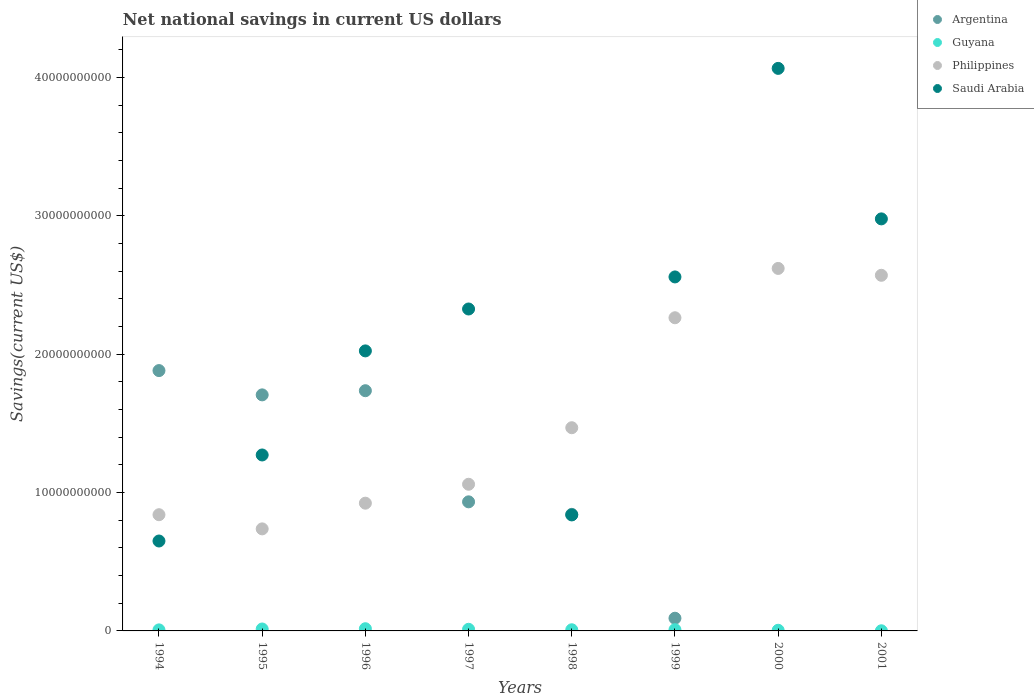Is the number of dotlines equal to the number of legend labels?
Give a very brief answer. No. What is the net national savings in Saudi Arabia in 1995?
Keep it short and to the point. 1.27e+1. Across all years, what is the maximum net national savings in Argentina?
Provide a succinct answer. 1.88e+1. Across all years, what is the minimum net national savings in Guyana?
Your response must be concise. 1.03e+07. In which year was the net national savings in Philippines maximum?
Make the answer very short. 2000. What is the total net national savings in Philippines in the graph?
Make the answer very short. 1.25e+11. What is the difference between the net national savings in Saudi Arabia in 1994 and that in 1997?
Your response must be concise. -1.68e+1. What is the difference between the net national savings in Saudi Arabia in 1998 and the net national savings in Argentina in 1995?
Your response must be concise. -8.68e+09. What is the average net national savings in Argentina per year?
Offer a very short reply. 8.99e+09. In the year 1996, what is the difference between the net national savings in Saudi Arabia and net national savings in Guyana?
Keep it short and to the point. 2.01e+1. What is the ratio of the net national savings in Saudi Arabia in 1995 to that in 1997?
Your answer should be very brief. 0.55. Is the net national savings in Saudi Arabia in 1997 less than that in 1998?
Provide a short and direct response. No. Is the difference between the net national savings in Saudi Arabia in 1995 and 2000 greater than the difference between the net national savings in Guyana in 1995 and 2000?
Make the answer very short. No. What is the difference between the highest and the second highest net national savings in Guyana?
Your answer should be compact. 1.91e+07. What is the difference between the highest and the lowest net national savings in Argentina?
Offer a terse response. 1.88e+1. Is the sum of the net national savings in Argentina in 1995 and 1996 greater than the maximum net national savings in Philippines across all years?
Your answer should be compact. Yes. Does the net national savings in Saudi Arabia monotonically increase over the years?
Offer a terse response. No. Is the net national savings in Guyana strictly greater than the net national savings in Argentina over the years?
Give a very brief answer. No. Is the net national savings in Saudi Arabia strictly less than the net national savings in Argentina over the years?
Your answer should be very brief. No. How many dotlines are there?
Your response must be concise. 4. How many years are there in the graph?
Make the answer very short. 8. What is the difference between two consecutive major ticks on the Y-axis?
Your answer should be very brief. 1.00e+1. Does the graph contain grids?
Offer a very short reply. No. How are the legend labels stacked?
Your answer should be very brief. Vertical. What is the title of the graph?
Ensure brevity in your answer.  Net national savings in current US dollars. What is the label or title of the Y-axis?
Provide a short and direct response. Savings(current US$). What is the Savings(current US$) of Argentina in 1994?
Make the answer very short. 1.88e+1. What is the Savings(current US$) of Guyana in 1994?
Ensure brevity in your answer.  7.51e+07. What is the Savings(current US$) in Philippines in 1994?
Offer a very short reply. 8.40e+09. What is the Savings(current US$) in Saudi Arabia in 1994?
Your answer should be very brief. 6.50e+09. What is the Savings(current US$) in Argentina in 1995?
Your answer should be compact. 1.71e+1. What is the Savings(current US$) of Guyana in 1995?
Provide a succinct answer. 1.39e+08. What is the Savings(current US$) in Philippines in 1995?
Provide a short and direct response. 7.38e+09. What is the Savings(current US$) in Saudi Arabia in 1995?
Give a very brief answer. 1.27e+1. What is the Savings(current US$) of Argentina in 1996?
Offer a very short reply. 1.74e+1. What is the Savings(current US$) of Guyana in 1996?
Make the answer very short. 1.58e+08. What is the Savings(current US$) of Philippines in 1996?
Make the answer very short. 9.23e+09. What is the Savings(current US$) of Saudi Arabia in 1996?
Provide a succinct answer. 2.02e+1. What is the Savings(current US$) in Argentina in 1997?
Keep it short and to the point. 9.33e+09. What is the Savings(current US$) of Guyana in 1997?
Make the answer very short. 1.18e+08. What is the Savings(current US$) of Philippines in 1997?
Your answer should be compact. 1.06e+1. What is the Savings(current US$) of Saudi Arabia in 1997?
Keep it short and to the point. 2.33e+1. What is the Savings(current US$) of Argentina in 1998?
Give a very brief answer. 8.43e+09. What is the Savings(current US$) of Guyana in 1998?
Your answer should be compact. 8.32e+07. What is the Savings(current US$) in Philippines in 1998?
Keep it short and to the point. 1.47e+1. What is the Savings(current US$) in Saudi Arabia in 1998?
Make the answer very short. 8.39e+09. What is the Savings(current US$) in Argentina in 1999?
Your answer should be very brief. 9.18e+08. What is the Savings(current US$) of Guyana in 1999?
Ensure brevity in your answer.  8.86e+07. What is the Savings(current US$) of Philippines in 1999?
Keep it short and to the point. 2.26e+1. What is the Savings(current US$) of Saudi Arabia in 1999?
Provide a succinct answer. 2.56e+1. What is the Savings(current US$) in Argentina in 2000?
Offer a very short reply. 0. What is the Savings(current US$) in Guyana in 2000?
Your answer should be very brief. 4.73e+07. What is the Savings(current US$) of Philippines in 2000?
Offer a very short reply. 2.62e+1. What is the Savings(current US$) of Saudi Arabia in 2000?
Keep it short and to the point. 4.07e+1. What is the Savings(current US$) in Argentina in 2001?
Your response must be concise. 0. What is the Savings(current US$) in Guyana in 2001?
Provide a succinct answer. 1.03e+07. What is the Savings(current US$) in Philippines in 2001?
Offer a terse response. 2.57e+1. What is the Savings(current US$) in Saudi Arabia in 2001?
Give a very brief answer. 2.98e+1. Across all years, what is the maximum Savings(current US$) of Argentina?
Make the answer very short. 1.88e+1. Across all years, what is the maximum Savings(current US$) of Guyana?
Offer a very short reply. 1.58e+08. Across all years, what is the maximum Savings(current US$) of Philippines?
Keep it short and to the point. 2.62e+1. Across all years, what is the maximum Savings(current US$) of Saudi Arabia?
Your response must be concise. 4.07e+1. Across all years, what is the minimum Savings(current US$) in Argentina?
Your answer should be compact. 0. Across all years, what is the minimum Savings(current US$) of Guyana?
Offer a very short reply. 1.03e+07. Across all years, what is the minimum Savings(current US$) in Philippines?
Keep it short and to the point. 7.38e+09. Across all years, what is the minimum Savings(current US$) in Saudi Arabia?
Your answer should be compact. 6.50e+09. What is the total Savings(current US$) in Argentina in the graph?
Provide a succinct answer. 7.19e+1. What is the total Savings(current US$) of Guyana in the graph?
Your answer should be compact. 7.20e+08. What is the total Savings(current US$) of Philippines in the graph?
Make the answer very short. 1.25e+11. What is the total Savings(current US$) in Saudi Arabia in the graph?
Make the answer very short. 1.67e+11. What is the difference between the Savings(current US$) in Argentina in 1994 and that in 1995?
Provide a succinct answer. 1.76e+09. What is the difference between the Savings(current US$) of Guyana in 1994 and that in 1995?
Offer a very short reply. -6.42e+07. What is the difference between the Savings(current US$) in Philippines in 1994 and that in 1995?
Your answer should be compact. 1.02e+09. What is the difference between the Savings(current US$) of Saudi Arabia in 1994 and that in 1995?
Your answer should be compact. -6.22e+09. What is the difference between the Savings(current US$) of Argentina in 1994 and that in 1996?
Provide a succinct answer. 1.45e+09. What is the difference between the Savings(current US$) in Guyana in 1994 and that in 1996?
Provide a short and direct response. -8.34e+07. What is the difference between the Savings(current US$) in Philippines in 1994 and that in 1996?
Offer a very short reply. -8.34e+08. What is the difference between the Savings(current US$) in Saudi Arabia in 1994 and that in 1996?
Your response must be concise. -1.37e+1. What is the difference between the Savings(current US$) of Argentina in 1994 and that in 1997?
Offer a terse response. 9.49e+09. What is the difference between the Savings(current US$) of Guyana in 1994 and that in 1997?
Ensure brevity in your answer.  -4.26e+07. What is the difference between the Savings(current US$) in Philippines in 1994 and that in 1997?
Provide a succinct answer. -2.20e+09. What is the difference between the Savings(current US$) of Saudi Arabia in 1994 and that in 1997?
Provide a succinct answer. -1.68e+1. What is the difference between the Savings(current US$) of Argentina in 1994 and that in 1998?
Your response must be concise. 1.04e+1. What is the difference between the Savings(current US$) of Guyana in 1994 and that in 1998?
Give a very brief answer. -8.11e+06. What is the difference between the Savings(current US$) of Philippines in 1994 and that in 1998?
Your response must be concise. -6.29e+09. What is the difference between the Savings(current US$) of Saudi Arabia in 1994 and that in 1998?
Offer a very short reply. -1.89e+09. What is the difference between the Savings(current US$) of Argentina in 1994 and that in 1999?
Your answer should be compact. 1.79e+1. What is the difference between the Savings(current US$) of Guyana in 1994 and that in 1999?
Give a very brief answer. -1.34e+07. What is the difference between the Savings(current US$) of Philippines in 1994 and that in 1999?
Your answer should be compact. -1.42e+1. What is the difference between the Savings(current US$) of Saudi Arabia in 1994 and that in 1999?
Give a very brief answer. -1.91e+1. What is the difference between the Savings(current US$) in Guyana in 1994 and that in 2000?
Provide a succinct answer. 2.78e+07. What is the difference between the Savings(current US$) of Philippines in 1994 and that in 2000?
Ensure brevity in your answer.  -1.78e+1. What is the difference between the Savings(current US$) of Saudi Arabia in 1994 and that in 2000?
Give a very brief answer. -3.42e+1. What is the difference between the Savings(current US$) in Guyana in 1994 and that in 2001?
Provide a succinct answer. 6.49e+07. What is the difference between the Savings(current US$) of Philippines in 1994 and that in 2001?
Offer a very short reply. -1.73e+1. What is the difference between the Savings(current US$) of Saudi Arabia in 1994 and that in 2001?
Your answer should be compact. -2.33e+1. What is the difference between the Savings(current US$) in Argentina in 1995 and that in 1996?
Your answer should be compact. -3.01e+08. What is the difference between the Savings(current US$) of Guyana in 1995 and that in 1996?
Your answer should be very brief. -1.91e+07. What is the difference between the Savings(current US$) of Philippines in 1995 and that in 1996?
Ensure brevity in your answer.  -1.86e+09. What is the difference between the Savings(current US$) in Saudi Arabia in 1995 and that in 1996?
Your answer should be compact. -7.52e+09. What is the difference between the Savings(current US$) of Argentina in 1995 and that in 1997?
Your response must be concise. 7.73e+09. What is the difference between the Savings(current US$) in Guyana in 1995 and that in 1997?
Provide a short and direct response. 2.16e+07. What is the difference between the Savings(current US$) of Philippines in 1995 and that in 1997?
Give a very brief answer. -3.23e+09. What is the difference between the Savings(current US$) in Saudi Arabia in 1995 and that in 1997?
Give a very brief answer. -1.06e+1. What is the difference between the Savings(current US$) of Argentina in 1995 and that in 1998?
Keep it short and to the point. 8.64e+09. What is the difference between the Savings(current US$) in Guyana in 1995 and that in 1998?
Ensure brevity in your answer.  5.61e+07. What is the difference between the Savings(current US$) of Philippines in 1995 and that in 1998?
Offer a very short reply. -7.31e+09. What is the difference between the Savings(current US$) in Saudi Arabia in 1995 and that in 1998?
Provide a short and direct response. 4.33e+09. What is the difference between the Savings(current US$) in Argentina in 1995 and that in 1999?
Ensure brevity in your answer.  1.61e+1. What is the difference between the Savings(current US$) of Guyana in 1995 and that in 1999?
Offer a terse response. 5.08e+07. What is the difference between the Savings(current US$) of Philippines in 1995 and that in 1999?
Provide a succinct answer. -1.53e+1. What is the difference between the Savings(current US$) of Saudi Arabia in 1995 and that in 1999?
Provide a succinct answer. -1.29e+1. What is the difference between the Savings(current US$) in Guyana in 1995 and that in 2000?
Make the answer very short. 9.21e+07. What is the difference between the Savings(current US$) of Philippines in 1995 and that in 2000?
Your response must be concise. -1.88e+1. What is the difference between the Savings(current US$) of Saudi Arabia in 1995 and that in 2000?
Provide a short and direct response. -2.79e+1. What is the difference between the Savings(current US$) of Guyana in 1995 and that in 2001?
Ensure brevity in your answer.  1.29e+08. What is the difference between the Savings(current US$) in Philippines in 1995 and that in 2001?
Offer a very short reply. -1.83e+1. What is the difference between the Savings(current US$) of Saudi Arabia in 1995 and that in 2001?
Provide a succinct answer. -1.71e+1. What is the difference between the Savings(current US$) in Argentina in 1996 and that in 1997?
Your answer should be compact. 8.03e+09. What is the difference between the Savings(current US$) of Guyana in 1996 and that in 1997?
Make the answer very short. 4.07e+07. What is the difference between the Savings(current US$) of Philippines in 1996 and that in 1997?
Provide a succinct answer. -1.37e+09. What is the difference between the Savings(current US$) of Saudi Arabia in 1996 and that in 1997?
Provide a succinct answer. -3.03e+09. What is the difference between the Savings(current US$) in Argentina in 1996 and that in 1998?
Your answer should be very brief. 8.94e+09. What is the difference between the Savings(current US$) of Guyana in 1996 and that in 1998?
Your answer should be very brief. 7.53e+07. What is the difference between the Savings(current US$) in Philippines in 1996 and that in 1998?
Provide a short and direct response. -5.45e+09. What is the difference between the Savings(current US$) in Saudi Arabia in 1996 and that in 1998?
Make the answer very short. 1.19e+1. What is the difference between the Savings(current US$) in Argentina in 1996 and that in 1999?
Keep it short and to the point. 1.64e+1. What is the difference between the Savings(current US$) of Guyana in 1996 and that in 1999?
Offer a terse response. 6.99e+07. What is the difference between the Savings(current US$) in Philippines in 1996 and that in 1999?
Ensure brevity in your answer.  -1.34e+1. What is the difference between the Savings(current US$) of Saudi Arabia in 1996 and that in 1999?
Offer a terse response. -5.35e+09. What is the difference between the Savings(current US$) in Guyana in 1996 and that in 2000?
Your answer should be very brief. 1.11e+08. What is the difference between the Savings(current US$) of Philippines in 1996 and that in 2000?
Keep it short and to the point. -1.70e+1. What is the difference between the Savings(current US$) of Saudi Arabia in 1996 and that in 2000?
Keep it short and to the point. -2.04e+1. What is the difference between the Savings(current US$) in Guyana in 1996 and that in 2001?
Your answer should be very brief. 1.48e+08. What is the difference between the Savings(current US$) in Philippines in 1996 and that in 2001?
Make the answer very short. -1.65e+1. What is the difference between the Savings(current US$) of Saudi Arabia in 1996 and that in 2001?
Your answer should be compact. -9.54e+09. What is the difference between the Savings(current US$) of Argentina in 1997 and that in 1998?
Your response must be concise. 9.04e+08. What is the difference between the Savings(current US$) in Guyana in 1997 and that in 1998?
Provide a succinct answer. 3.45e+07. What is the difference between the Savings(current US$) of Philippines in 1997 and that in 1998?
Ensure brevity in your answer.  -4.09e+09. What is the difference between the Savings(current US$) of Saudi Arabia in 1997 and that in 1998?
Make the answer very short. 1.49e+1. What is the difference between the Savings(current US$) in Argentina in 1997 and that in 1999?
Your answer should be compact. 8.41e+09. What is the difference between the Savings(current US$) in Guyana in 1997 and that in 1999?
Provide a short and direct response. 2.92e+07. What is the difference between the Savings(current US$) in Philippines in 1997 and that in 1999?
Your answer should be very brief. -1.20e+1. What is the difference between the Savings(current US$) in Saudi Arabia in 1997 and that in 1999?
Offer a terse response. -2.32e+09. What is the difference between the Savings(current US$) of Guyana in 1997 and that in 2000?
Your response must be concise. 7.05e+07. What is the difference between the Savings(current US$) in Philippines in 1997 and that in 2000?
Provide a short and direct response. -1.56e+1. What is the difference between the Savings(current US$) of Saudi Arabia in 1997 and that in 2000?
Offer a very short reply. -1.74e+1. What is the difference between the Savings(current US$) in Guyana in 1997 and that in 2001?
Offer a very short reply. 1.07e+08. What is the difference between the Savings(current US$) of Philippines in 1997 and that in 2001?
Ensure brevity in your answer.  -1.51e+1. What is the difference between the Savings(current US$) of Saudi Arabia in 1997 and that in 2001?
Provide a short and direct response. -6.51e+09. What is the difference between the Savings(current US$) of Argentina in 1998 and that in 1999?
Keep it short and to the point. 7.51e+09. What is the difference between the Savings(current US$) in Guyana in 1998 and that in 1999?
Your response must be concise. -5.34e+06. What is the difference between the Savings(current US$) of Philippines in 1998 and that in 1999?
Keep it short and to the point. -7.95e+09. What is the difference between the Savings(current US$) in Saudi Arabia in 1998 and that in 1999?
Your answer should be compact. -1.72e+1. What is the difference between the Savings(current US$) in Guyana in 1998 and that in 2000?
Ensure brevity in your answer.  3.59e+07. What is the difference between the Savings(current US$) of Philippines in 1998 and that in 2000?
Your answer should be very brief. -1.15e+1. What is the difference between the Savings(current US$) of Saudi Arabia in 1998 and that in 2000?
Offer a terse response. -3.23e+1. What is the difference between the Savings(current US$) in Guyana in 1998 and that in 2001?
Provide a short and direct response. 7.30e+07. What is the difference between the Savings(current US$) of Philippines in 1998 and that in 2001?
Provide a short and direct response. -1.10e+1. What is the difference between the Savings(current US$) in Saudi Arabia in 1998 and that in 2001?
Provide a short and direct response. -2.14e+1. What is the difference between the Savings(current US$) in Guyana in 1999 and that in 2000?
Provide a succinct answer. 4.13e+07. What is the difference between the Savings(current US$) in Philippines in 1999 and that in 2000?
Provide a succinct answer. -3.57e+09. What is the difference between the Savings(current US$) in Saudi Arabia in 1999 and that in 2000?
Provide a short and direct response. -1.51e+1. What is the difference between the Savings(current US$) of Guyana in 1999 and that in 2001?
Your response must be concise. 7.83e+07. What is the difference between the Savings(current US$) in Philippines in 1999 and that in 2001?
Make the answer very short. -3.07e+09. What is the difference between the Savings(current US$) of Saudi Arabia in 1999 and that in 2001?
Keep it short and to the point. -4.20e+09. What is the difference between the Savings(current US$) in Guyana in 2000 and that in 2001?
Give a very brief answer. 3.70e+07. What is the difference between the Savings(current US$) of Philippines in 2000 and that in 2001?
Keep it short and to the point. 4.96e+08. What is the difference between the Savings(current US$) in Saudi Arabia in 2000 and that in 2001?
Give a very brief answer. 1.09e+1. What is the difference between the Savings(current US$) of Argentina in 1994 and the Savings(current US$) of Guyana in 1995?
Provide a succinct answer. 1.87e+1. What is the difference between the Savings(current US$) in Argentina in 1994 and the Savings(current US$) in Philippines in 1995?
Keep it short and to the point. 1.14e+1. What is the difference between the Savings(current US$) of Argentina in 1994 and the Savings(current US$) of Saudi Arabia in 1995?
Offer a terse response. 6.10e+09. What is the difference between the Savings(current US$) in Guyana in 1994 and the Savings(current US$) in Philippines in 1995?
Your answer should be compact. -7.30e+09. What is the difference between the Savings(current US$) of Guyana in 1994 and the Savings(current US$) of Saudi Arabia in 1995?
Provide a succinct answer. -1.26e+1. What is the difference between the Savings(current US$) of Philippines in 1994 and the Savings(current US$) of Saudi Arabia in 1995?
Your answer should be very brief. -4.32e+09. What is the difference between the Savings(current US$) of Argentina in 1994 and the Savings(current US$) of Guyana in 1996?
Provide a succinct answer. 1.87e+1. What is the difference between the Savings(current US$) of Argentina in 1994 and the Savings(current US$) of Philippines in 1996?
Provide a short and direct response. 9.58e+09. What is the difference between the Savings(current US$) in Argentina in 1994 and the Savings(current US$) in Saudi Arabia in 1996?
Provide a short and direct response. -1.42e+09. What is the difference between the Savings(current US$) in Guyana in 1994 and the Savings(current US$) in Philippines in 1996?
Offer a very short reply. -9.16e+09. What is the difference between the Savings(current US$) in Guyana in 1994 and the Savings(current US$) in Saudi Arabia in 1996?
Keep it short and to the point. -2.02e+1. What is the difference between the Savings(current US$) of Philippines in 1994 and the Savings(current US$) of Saudi Arabia in 1996?
Your answer should be very brief. -1.18e+1. What is the difference between the Savings(current US$) in Argentina in 1994 and the Savings(current US$) in Guyana in 1997?
Provide a succinct answer. 1.87e+1. What is the difference between the Savings(current US$) in Argentina in 1994 and the Savings(current US$) in Philippines in 1997?
Your response must be concise. 8.22e+09. What is the difference between the Savings(current US$) in Argentina in 1994 and the Savings(current US$) in Saudi Arabia in 1997?
Provide a short and direct response. -4.45e+09. What is the difference between the Savings(current US$) of Guyana in 1994 and the Savings(current US$) of Philippines in 1997?
Your answer should be compact. -1.05e+1. What is the difference between the Savings(current US$) in Guyana in 1994 and the Savings(current US$) in Saudi Arabia in 1997?
Provide a short and direct response. -2.32e+1. What is the difference between the Savings(current US$) in Philippines in 1994 and the Savings(current US$) in Saudi Arabia in 1997?
Provide a short and direct response. -1.49e+1. What is the difference between the Savings(current US$) in Argentina in 1994 and the Savings(current US$) in Guyana in 1998?
Give a very brief answer. 1.87e+1. What is the difference between the Savings(current US$) in Argentina in 1994 and the Savings(current US$) in Philippines in 1998?
Keep it short and to the point. 4.13e+09. What is the difference between the Savings(current US$) of Argentina in 1994 and the Savings(current US$) of Saudi Arabia in 1998?
Your answer should be compact. 1.04e+1. What is the difference between the Savings(current US$) in Guyana in 1994 and the Savings(current US$) in Philippines in 1998?
Offer a terse response. -1.46e+1. What is the difference between the Savings(current US$) in Guyana in 1994 and the Savings(current US$) in Saudi Arabia in 1998?
Provide a succinct answer. -8.31e+09. What is the difference between the Savings(current US$) of Philippines in 1994 and the Savings(current US$) of Saudi Arabia in 1998?
Offer a terse response. 1.50e+07. What is the difference between the Savings(current US$) in Argentina in 1994 and the Savings(current US$) in Guyana in 1999?
Ensure brevity in your answer.  1.87e+1. What is the difference between the Savings(current US$) of Argentina in 1994 and the Savings(current US$) of Philippines in 1999?
Offer a terse response. -3.82e+09. What is the difference between the Savings(current US$) in Argentina in 1994 and the Savings(current US$) in Saudi Arabia in 1999?
Provide a short and direct response. -6.77e+09. What is the difference between the Savings(current US$) in Guyana in 1994 and the Savings(current US$) in Philippines in 1999?
Your answer should be compact. -2.26e+1. What is the difference between the Savings(current US$) of Guyana in 1994 and the Savings(current US$) of Saudi Arabia in 1999?
Make the answer very short. -2.55e+1. What is the difference between the Savings(current US$) of Philippines in 1994 and the Savings(current US$) of Saudi Arabia in 1999?
Your response must be concise. -1.72e+1. What is the difference between the Savings(current US$) in Argentina in 1994 and the Savings(current US$) in Guyana in 2000?
Ensure brevity in your answer.  1.88e+1. What is the difference between the Savings(current US$) of Argentina in 1994 and the Savings(current US$) of Philippines in 2000?
Ensure brevity in your answer.  -7.39e+09. What is the difference between the Savings(current US$) of Argentina in 1994 and the Savings(current US$) of Saudi Arabia in 2000?
Your answer should be very brief. -2.18e+1. What is the difference between the Savings(current US$) of Guyana in 1994 and the Savings(current US$) of Philippines in 2000?
Your answer should be very brief. -2.61e+1. What is the difference between the Savings(current US$) of Guyana in 1994 and the Savings(current US$) of Saudi Arabia in 2000?
Provide a short and direct response. -4.06e+1. What is the difference between the Savings(current US$) in Philippines in 1994 and the Savings(current US$) in Saudi Arabia in 2000?
Provide a succinct answer. -3.23e+1. What is the difference between the Savings(current US$) in Argentina in 1994 and the Savings(current US$) in Guyana in 2001?
Offer a terse response. 1.88e+1. What is the difference between the Savings(current US$) in Argentina in 1994 and the Savings(current US$) in Philippines in 2001?
Make the answer very short. -6.89e+09. What is the difference between the Savings(current US$) of Argentina in 1994 and the Savings(current US$) of Saudi Arabia in 2001?
Keep it short and to the point. -1.10e+1. What is the difference between the Savings(current US$) of Guyana in 1994 and the Savings(current US$) of Philippines in 2001?
Your answer should be very brief. -2.56e+1. What is the difference between the Savings(current US$) in Guyana in 1994 and the Savings(current US$) in Saudi Arabia in 2001?
Provide a succinct answer. -2.97e+1. What is the difference between the Savings(current US$) in Philippines in 1994 and the Savings(current US$) in Saudi Arabia in 2001?
Offer a very short reply. -2.14e+1. What is the difference between the Savings(current US$) in Argentina in 1995 and the Savings(current US$) in Guyana in 1996?
Your answer should be very brief. 1.69e+1. What is the difference between the Savings(current US$) of Argentina in 1995 and the Savings(current US$) of Philippines in 1996?
Make the answer very short. 7.83e+09. What is the difference between the Savings(current US$) in Argentina in 1995 and the Savings(current US$) in Saudi Arabia in 1996?
Give a very brief answer. -3.18e+09. What is the difference between the Savings(current US$) in Guyana in 1995 and the Savings(current US$) in Philippines in 1996?
Provide a short and direct response. -9.09e+09. What is the difference between the Savings(current US$) of Guyana in 1995 and the Savings(current US$) of Saudi Arabia in 1996?
Your response must be concise. -2.01e+1. What is the difference between the Savings(current US$) in Philippines in 1995 and the Savings(current US$) in Saudi Arabia in 1996?
Provide a short and direct response. -1.29e+1. What is the difference between the Savings(current US$) in Argentina in 1995 and the Savings(current US$) in Guyana in 1997?
Give a very brief answer. 1.69e+1. What is the difference between the Savings(current US$) of Argentina in 1995 and the Savings(current US$) of Philippines in 1997?
Give a very brief answer. 6.46e+09. What is the difference between the Savings(current US$) of Argentina in 1995 and the Savings(current US$) of Saudi Arabia in 1997?
Your answer should be very brief. -6.21e+09. What is the difference between the Savings(current US$) of Guyana in 1995 and the Savings(current US$) of Philippines in 1997?
Your answer should be compact. -1.05e+1. What is the difference between the Savings(current US$) in Guyana in 1995 and the Savings(current US$) in Saudi Arabia in 1997?
Offer a very short reply. -2.31e+1. What is the difference between the Savings(current US$) of Philippines in 1995 and the Savings(current US$) of Saudi Arabia in 1997?
Give a very brief answer. -1.59e+1. What is the difference between the Savings(current US$) in Argentina in 1995 and the Savings(current US$) in Guyana in 1998?
Offer a terse response. 1.70e+1. What is the difference between the Savings(current US$) in Argentina in 1995 and the Savings(current US$) in Philippines in 1998?
Offer a terse response. 2.37e+09. What is the difference between the Savings(current US$) in Argentina in 1995 and the Savings(current US$) in Saudi Arabia in 1998?
Ensure brevity in your answer.  8.68e+09. What is the difference between the Savings(current US$) in Guyana in 1995 and the Savings(current US$) in Philippines in 1998?
Give a very brief answer. -1.45e+1. What is the difference between the Savings(current US$) in Guyana in 1995 and the Savings(current US$) in Saudi Arabia in 1998?
Your answer should be compact. -8.25e+09. What is the difference between the Savings(current US$) of Philippines in 1995 and the Savings(current US$) of Saudi Arabia in 1998?
Keep it short and to the point. -1.01e+09. What is the difference between the Savings(current US$) in Argentina in 1995 and the Savings(current US$) in Guyana in 1999?
Offer a very short reply. 1.70e+1. What is the difference between the Savings(current US$) in Argentina in 1995 and the Savings(current US$) in Philippines in 1999?
Offer a terse response. -5.57e+09. What is the difference between the Savings(current US$) in Argentina in 1995 and the Savings(current US$) in Saudi Arabia in 1999?
Your answer should be compact. -8.53e+09. What is the difference between the Savings(current US$) in Guyana in 1995 and the Savings(current US$) in Philippines in 1999?
Provide a succinct answer. -2.25e+1. What is the difference between the Savings(current US$) of Guyana in 1995 and the Savings(current US$) of Saudi Arabia in 1999?
Ensure brevity in your answer.  -2.54e+1. What is the difference between the Savings(current US$) in Philippines in 1995 and the Savings(current US$) in Saudi Arabia in 1999?
Offer a very short reply. -1.82e+1. What is the difference between the Savings(current US$) of Argentina in 1995 and the Savings(current US$) of Guyana in 2000?
Provide a succinct answer. 1.70e+1. What is the difference between the Savings(current US$) of Argentina in 1995 and the Savings(current US$) of Philippines in 2000?
Provide a short and direct response. -9.14e+09. What is the difference between the Savings(current US$) in Argentina in 1995 and the Savings(current US$) in Saudi Arabia in 2000?
Give a very brief answer. -2.36e+1. What is the difference between the Savings(current US$) in Guyana in 1995 and the Savings(current US$) in Philippines in 2000?
Your answer should be very brief. -2.61e+1. What is the difference between the Savings(current US$) in Guyana in 1995 and the Savings(current US$) in Saudi Arabia in 2000?
Provide a short and direct response. -4.05e+1. What is the difference between the Savings(current US$) of Philippines in 1995 and the Savings(current US$) of Saudi Arabia in 2000?
Make the answer very short. -3.33e+1. What is the difference between the Savings(current US$) of Argentina in 1995 and the Savings(current US$) of Guyana in 2001?
Make the answer very short. 1.71e+1. What is the difference between the Savings(current US$) in Argentina in 1995 and the Savings(current US$) in Philippines in 2001?
Provide a short and direct response. -8.64e+09. What is the difference between the Savings(current US$) of Argentina in 1995 and the Savings(current US$) of Saudi Arabia in 2001?
Offer a very short reply. -1.27e+1. What is the difference between the Savings(current US$) in Guyana in 1995 and the Savings(current US$) in Philippines in 2001?
Your answer should be very brief. -2.56e+1. What is the difference between the Savings(current US$) of Guyana in 1995 and the Savings(current US$) of Saudi Arabia in 2001?
Keep it short and to the point. -2.96e+1. What is the difference between the Savings(current US$) of Philippines in 1995 and the Savings(current US$) of Saudi Arabia in 2001?
Your answer should be very brief. -2.24e+1. What is the difference between the Savings(current US$) of Argentina in 1996 and the Savings(current US$) of Guyana in 1997?
Provide a succinct answer. 1.72e+1. What is the difference between the Savings(current US$) of Argentina in 1996 and the Savings(current US$) of Philippines in 1997?
Offer a terse response. 6.76e+09. What is the difference between the Savings(current US$) in Argentina in 1996 and the Savings(current US$) in Saudi Arabia in 1997?
Make the answer very short. -5.91e+09. What is the difference between the Savings(current US$) in Guyana in 1996 and the Savings(current US$) in Philippines in 1997?
Provide a short and direct response. -1.04e+1. What is the difference between the Savings(current US$) of Guyana in 1996 and the Savings(current US$) of Saudi Arabia in 1997?
Your response must be concise. -2.31e+1. What is the difference between the Savings(current US$) in Philippines in 1996 and the Savings(current US$) in Saudi Arabia in 1997?
Offer a terse response. -1.40e+1. What is the difference between the Savings(current US$) of Argentina in 1996 and the Savings(current US$) of Guyana in 1998?
Your response must be concise. 1.73e+1. What is the difference between the Savings(current US$) of Argentina in 1996 and the Savings(current US$) of Philippines in 1998?
Provide a short and direct response. 2.68e+09. What is the difference between the Savings(current US$) in Argentina in 1996 and the Savings(current US$) in Saudi Arabia in 1998?
Keep it short and to the point. 8.98e+09. What is the difference between the Savings(current US$) of Guyana in 1996 and the Savings(current US$) of Philippines in 1998?
Ensure brevity in your answer.  -1.45e+1. What is the difference between the Savings(current US$) of Guyana in 1996 and the Savings(current US$) of Saudi Arabia in 1998?
Your answer should be compact. -8.23e+09. What is the difference between the Savings(current US$) in Philippines in 1996 and the Savings(current US$) in Saudi Arabia in 1998?
Provide a short and direct response. 8.49e+08. What is the difference between the Savings(current US$) in Argentina in 1996 and the Savings(current US$) in Guyana in 1999?
Give a very brief answer. 1.73e+1. What is the difference between the Savings(current US$) of Argentina in 1996 and the Savings(current US$) of Philippines in 1999?
Provide a succinct answer. -5.27e+09. What is the difference between the Savings(current US$) in Argentina in 1996 and the Savings(current US$) in Saudi Arabia in 1999?
Your response must be concise. -8.22e+09. What is the difference between the Savings(current US$) of Guyana in 1996 and the Savings(current US$) of Philippines in 1999?
Your answer should be very brief. -2.25e+1. What is the difference between the Savings(current US$) in Guyana in 1996 and the Savings(current US$) in Saudi Arabia in 1999?
Your answer should be very brief. -2.54e+1. What is the difference between the Savings(current US$) of Philippines in 1996 and the Savings(current US$) of Saudi Arabia in 1999?
Ensure brevity in your answer.  -1.64e+1. What is the difference between the Savings(current US$) in Argentina in 1996 and the Savings(current US$) in Guyana in 2000?
Ensure brevity in your answer.  1.73e+1. What is the difference between the Savings(current US$) in Argentina in 1996 and the Savings(current US$) in Philippines in 2000?
Your answer should be very brief. -8.84e+09. What is the difference between the Savings(current US$) of Argentina in 1996 and the Savings(current US$) of Saudi Arabia in 2000?
Provide a succinct answer. -2.33e+1. What is the difference between the Savings(current US$) in Guyana in 1996 and the Savings(current US$) in Philippines in 2000?
Offer a very short reply. -2.60e+1. What is the difference between the Savings(current US$) in Guyana in 1996 and the Savings(current US$) in Saudi Arabia in 2000?
Offer a very short reply. -4.05e+1. What is the difference between the Savings(current US$) in Philippines in 1996 and the Savings(current US$) in Saudi Arabia in 2000?
Your answer should be compact. -3.14e+1. What is the difference between the Savings(current US$) of Argentina in 1996 and the Savings(current US$) of Guyana in 2001?
Ensure brevity in your answer.  1.74e+1. What is the difference between the Savings(current US$) in Argentina in 1996 and the Savings(current US$) in Philippines in 2001?
Keep it short and to the point. -8.34e+09. What is the difference between the Savings(current US$) of Argentina in 1996 and the Savings(current US$) of Saudi Arabia in 2001?
Ensure brevity in your answer.  -1.24e+1. What is the difference between the Savings(current US$) of Guyana in 1996 and the Savings(current US$) of Philippines in 2001?
Provide a succinct answer. -2.55e+1. What is the difference between the Savings(current US$) of Guyana in 1996 and the Savings(current US$) of Saudi Arabia in 2001?
Make the answer very short. -2.96e+1. What is the difference between the Savings(current US$) in Philippines in 1996 and the Savings(current US$) in Saudi Arabia in 2001?
Offer a very short reply. -2.06e+1. What is the difference between the Savings(current US$) of Argentina in 1997 and the Savings(current US$) of Guyana in 1998?
Offer a very short reply. 9.25e+09. What is the difference between the Savings(current US$) of Argentina in 1997 and the Savings(current US$) of Philippines in 1998?
Give a very brief answer. -5.36e+09. What is the difference between the Savings(current US$) of Argentina in 1997 and the Savings(current US$) of Saudi Arabia in 1998?
Provide a short and direct response. 9.46e+08. What is the difference between the Savings(current US$) of Guyana in 1997 and the Savings(current US$) of Philippines in 1998?
Your answer should be very brief. -1.46e+1. What is the difference between the Savings(current US$) of Guyana in 1997 and the Savings(current US$) of Saudi Arabia in 1998?
Provide a short and direct response. -8.27e+09. What is the difference between the Savings(current US$) of Philippines in 1997 and the Savings(current US$) of Saudi Arabia in 1998?
Your response must be concise. 2.22e+09. What is the difference between the Savings(current US$) in Argentina in 1997 and the Savings(current US$) in Guyana in 1999?
Your response must be concise. 9.24e+09. What is the difference between the Savings(current US$) in Argentina in 1997 and the Savings(current US$) in Philippines in 1999?
Make the answer very short. -1.33e+1. What is the difference between the Savings(current US$) of Argentina in 1997 and the Savings(current US$) of Saudi Arabia in 1999?
Provide a short and direct response. -1.63e+1. What is the difference between the Savings(current US$) in Guyana in 1997 and the Savings(current US$) in Philippines in 1999?
Make the answer very short. -2.25e+1. What is the difference between the Savings(current US$) of Guyana in 1997 and the Savings(current US$) of Saudi Arabia in 1999?
Offer a very short reply. -2.55e+1. What is the difference between the Savings(current US$) in Philippines in 1997 and the Savings(current US$) in Saudi Arabia in 1999?
Make the answer very short. -1.50e+1. What is the difference between the Savings(current US$) in Argentina in 1997 and the Savings(current US$) in Guyana in 2000?
Your answer should be very brief. 9.28e+09. What is the difference between the Savings(current US$) of Argentina in 1997 and the Savings(current US$) of Philippines in 2000?
Provide a short and direct response. -1.69e+1. What is the difference between the Savings(current US$) in Argentina in 1997 and the Savings(current US$) in Saudi Arabia in 2000?
Ensure brevity in your answer.  -3.13e+1. What is the difference between the Savings(current US$) in Guyana in 1997 and the Savings(current US$) in Philippines in 2000?
Make the answer very short. -2.61e+1. What is the difference between the Savings(current US$) in Guyana in 1997 and the Savings(current US$) in Saudi Arabia in 2000?
Make the answer very short. -4.05e+1. What is the difference between the Savings(current US$) of Philippines in 1997 and the Savings(current US$) of Saudi Arabia in 2000?
Provide a short and direct response. -3.01e+1. What is the difference between the Savings(current US$) in Argentina in 1997 and the Savings(current US$) in Guyana in 2001?
Your response must be concise. 9.32e+09. What is the difference between the Savings(current US$) in Argentina in 1997 and the Savings(current US$) in Philippines in 2001?
Keep it short and to the point. -1.64e+1. What is the difference between the Savings(current US$) in Argentina in 1997 and the Savings(current US$) in Saudi Arabia in 2001?
Offer a terse response. -2.05e+1. What is the difference between the Savings(current US$) of Guyana in 1997 and the Savings(current US$) of Philippines in 2001?
Provide a succinct answer. -2.56e+1. What is the difference between the Savings(current US$) of Guyana in 1997 and the Savings(current US$) of Saudi Arabia in 2001?
Offer a terse response. -2.97e+1. What is the difference between the Savings(current US$) in Philippines in 1997 and the Savings(current US$) in Saudi Arabia in 2001?
Your response must be concise. -1.92e+1. What is the difference between the Savings(current US$) of Argentina in 1998 and the Savings(current US$) of Guyana in 1999?
Provide a short and direct response. 8.34e+09. What is the difference between the Savings(current US$) in Argentina in 1998 and the Savings(current US$) in Philippines in 1999?
Provide a succinct answer. -1.42e+1. What is the difference between the Savings(current US$) in Argentina in 1998 and the Savings(current US$) in Saudi Arabia in 1999?
Your response must be concise. -1.72e+1. What is the difference between the Savings(current US$) of Guyana in 1998 and the Savings(current US$) of Philippines in 1999?
Provide a succinct answer. -2.26e+1. What is the difference between the Savings(current US$) in Guyana in 1998 and the Savings(current US$) in Saudi Arabia in 1999?
Your response must be concise. -2.55e+1. What is the difference between the Savings(current US$) in Philippines in 1998 and the Savings(current US$) in Saudi Arabia in 1999?
Offer a very short reply. -1.09e+1. What is the difference between the Savings(current US$) of Argentina in 1998 and the Savings(current US$) of Guyana in 2000?
Make the answer very short. 8.38e+09. What is the difference between the Savings(current US$) in Argentina in 1998 and the Savings(current US$) in Philippines in 2000?
Your response must be concise. -1.78e+1. What is the difference between the Savings(current US$) of Argentina in 1998 and the Savings(current US$) of Saudi Arabia in 2000?
Provide a succinct answer. -3.22e+1. What is the difference between the Savings(current US$) of Guyana in 1998 and the Savings(current US$) of Philippines in 2000?
Keep it short and to the point. -2.61e+1. What is the difference between the Savings(current US$) in Guyana in 1998 and the Savings(current US$) in Saudi Arabia in 2000?
Give a very brief answer. -4.06e+1. What is the difference between the Savings(current US$) in Philippines in 1998 and the Savings(current US$) in Saudi Arabia in 2000?
Your response must be concise. -2.60e+1. What is the difference between the Savings(current US$) in Argentina in 1998 and the Savings(current US$) in Guyana in 2001?
Make the answer very short. 8.42e+09. What is the difference between the Savings(current US$) in Argentina in 1998 and the Savings(current US$) in Philippines in 2001?
Provide a short and direct response. -1.73e+1. What is the difference between the Savings(current US$) of Argentina in 1998 and the Savings(current US$) of Saudi Arabia in 2001?
Keep it short and to the point. -2.14e+1. What is the difference between the Savings(current US$) of Guyana in 1998 and the Savings(current US$) of Philippines in 2001?
Your answer should be compact. -2.56e+1. What is the difference between the Savings(current US$) in Guyana in 1998 and the Savings(current US$) in Saudi Arabia in 2001?
Ensure brevity in your answer.  -2.97e+1. What is the difference between the Savings(current US$) in Philippines in 1998 and the Savings(current US$) in Saudi Arabia in 2001?
Make the answer very short. -1.51e+1. What is the difference between the Savings(current US$) of Argentina in 1999 and the Savings(current US$) of Guyana in 2000?
Ensure brevity in your answer.  8.71e+08. What is the difference between the Savings(current US$) in Argentina in 1999 and the Savings(current US$) in Philippines in 2000?
Your answer should be very brief. -2.53e+1. What is the difference between the Savings(current US$) in Argentina in 1999 and the Savings(current US$) in Saudi Arabia in 2000?
Your answer should be very brief. -3.97e+1. What is the difference between the Savings(current US$) in Guyana in 1999 and the Savings(current US$) in Philippines in 2000?
Offer a very short reply. -2.61e+1. What is the difference between the Savings(current US$) of Guyana in 1999 and the Savings(current US$) of Saudi Arabia in 2000?
Your response must be concise. -4.06e+1. What is the difference between the Savings(current US$) in Philippines in 1999 and the Savings(current US$) in Saudi Arabia in 2000?
Your response must be concise. -1.80e+1. What is the difference between the Savings(current US$) in Argentina in 1999 and the Savings(current US$) in Guyana in 2001?
Offer a terse response. 9.08e+08. What is the difference between the Savings(current US$) of Argentina in 1999 and the Savings(current US$) of Philippines in 2001?
Make the answer very short. -2.48e+1. What is the difference between the Savings(current US$) in Argentina in 1999 and the Savings(current US$) in Saudi Arabia in 2001?
Offer a terse response. -2.89e+1. What is the difference between the Savings(current US$) of Guyana in 1999 and the Savings(current US$) of Philippines in 2001?
Your answer should be very brief. -2.56e+1. What is the difference between the Savings(current US$) of Guyana in 1999 and the Savings(current US$) of Saudi Arabia in 2001?
Give a very brief answer. -2.97e+1. What is the difference between the Savings(current US$) of Philippines in 1999 and the Savings(current US$) of Saudi Arabia in 2001?
Ensure brevity in your answer.  -7.15e+09. What is the difference between the Savings(current US$) in Guyana in 2000 and the Savings(current US$) in Philippines in 2001?
Provide a succinct answer. -2.57e+1. What is the difference between the Savings(current US$) in Guyana in 2000 and the Savings(current US$) in Saudi Arabia in 2001?
Make the answer very short. -2.97e+1. What is the difference between the Savings(current US$) in Philippines in 2000 and the Savings(current US$) in Saudi Arabia in 2001?
Give a very brief answer. -3.58e+09. What is the average Savings(current US$) in Argentina per year?
Make the answer very short. 8.99e+09. What is the average Savings(current US$) in Guyana per year?
Ensure brevity in your answer.  9.00e+07. What is the average Savings(current US$) in Philippines per year?
Provide a short and direct response. 1.56e+1. What is the average Savings(current US$) in Saudi Arabia per year?
Give a very brief answer. 2.09e+1. In the year 1994, what is the difference between the Savings(current US$) in Argentina and Savings(current US$) in Guyana?
Offer a terse response. 1.87e+1. In the year 1994, what is the difference between the Savings(current US$) in Argentina and Savings(current US$) in Philippines?
Provide a succinct answer. 1.04e+1. In the year 1994, what is the difference between the Savings(current US$) of Argentina and Savings(current US$) of Saudi Arabia?
Provide a succinct answer. 1.23e+1. In the year 1994, what is the difference between the Savings(current US$) in Guyana and Savings(current US$) in Philippines?
Your answer should be compact. -8.33e+09. In the year 1994, what is the difference between the Savings(current US$) of Guyana and Savings(current US$) of Saudi Arabia?
Provide a short and direct response. -6.42e+09. In the year 1994, what is the difference between the Savings(current US$) of Philippines and Savings(current US$) of Saudi Arabia?
Your answer should be very brief. 1.90e+09. In the year 1995, what is the difference between the Savings(current US$) of Argentina and Savings(current US$) of Guyana?
Provide a short and direct response. 1.69e+1. In the year 1995, what is the difference between the Savings(current US$) of Argentina and Savings(current US$) of Philippines?
Keep it short and to the point. 9.69e+09. In the year 1995, what is the difference between the Savings(current US$) of Argentina and Savings(current US$) of Saudi Arabia?
Ensure brevity in your answer.  4.34e+09. In the year 1995, what is the difference between the Savings(current US$) of Guyana and Savings(current US$) of Philippines?
Give a very brief answer. -7.24e+09. In the year 1995, what is the difference between the Savings(current US$) in Guyana and Savings(current US$) in Saudi Arabia?
Offer a very short reply. -1.26e+1. In the year 1995, what is the difference between the Savings(current US$) of Philippines and Savings(current US$) of Saudi Arabia?
Offer a terse response. -5.34e+09. In the year 1996, what is the difference between the Savings(current US$) of Argentina and Savings(current US$) of Guyana?
Offer a very short reply. 1.72e+1. In the year 1996, what is the difference between the Savings(current US$) of Argentina and Savings(current US$) of Philippines?
Offer a terse response. 8.13e+09. In the year 1996, what is the difference between the Savings(current US$) in Argentina and Savings(current US$) in Saudi Arabia?
Provide a succinct answer. -2.88e+09. In the year 1996, what is the difference between the Savings(current US$) in Guyana and Savings(current US$) in Philippines?
Give a very brief answer. -9.08e+09. In the year 1996, what is the difference between the Savings(current US$) in Guyana and Savings(current US$) in Saudi Arabia?
Offer a terse response. -2.01e+1. In the year 1996, what is the difference between the Savings(current US$) in Philippines and Savings(current US$) in Saudi Arabia?
Your response must be concise. -1.10e+1. In the year 1997, what is the difference between the Savings(current US$) in Argentina and Savings(current US$) in Guyana?
Your answer should be compact. 9.21e+09. In the year 1997, what is the difference between the Savings(current US$) in Argentina and Savings(current US$) in Philippines?
Your answer should be compact. -1.27e+09. In the year 1997, what is the difference between the Savings(current US$) in Argentina and Savings(current US$) in Saudi Arabia?
Offer a terse response. -1.39e+1. In the year 1997, what is the difference between the Savings(current US$) in Guyana and Savings(current US$) in Philippines?
Offer a very short reply. -1.05e+1. In the year 1997, what is the difference between the Savings(current US$) of Guyana and Savings(current US$) of Saudi Arabia?
Give a very brief answer. -2.32e+1. In the year 1997, what is the difference between the Savings(current US$) of Philippines and Savings(current US$) of Saudi Arabia?
Give a very brief answer. -1.27e+1. In the year 1998, what is the difference between the Savings(current US$) in Argentina and Savings(current US$) in Guyana?
Provide a succinct answer. 8.34e+09. In the year 1998, what is the difference between the Savings(current US$) of Argentina and Savings(current US$) of Philippines?
Your answer should be very brief. -6.26e+09. In the year 1998, what is the difference between the Savings(current US$) of Argentina and Savings(current US$) of Saudi Arabia?
Your answer should be compact. 4.22e+07. In the year 1998, what is the difference between the Savings(current US$) in Guyana and Savings(current US$) in Philippines?
Ensure brevity in your answer.  -1.46e+1. In the year 1998, what is the difference between the Savings(current US$) in Guyana and Savings(current US$) in Saudi Arabia?
Your response must be concise. -8.30e+09. In the year 1998, what is the difference between the Savings(current US$) of Philippines and Savings(current US$) of Saudi Arabia?
Offer a terse response. 6.30e+09. In the year 1999, what is the difference between the Savings(current US$) in Argentina and Savings(current US$) in Guyana?
Offer a terse response. 8.30e+08. In the year 1999, what is the difference between the Savings(current US$) of Argentina and Savings(current US$) of Philippines?
Your answer should be very brief. -2.17e+1. In the year 1999, what is the difference between the Savings(current US$) in Argentina and Savings(current US$) in Saudi Arabia?
Keep it short and to the point. -2.47e+1. In the year 1999, what is the difference between the Savings(current US$) of Guyana and Savings(current US$) of Philippines?
Provide a short and direct response. -2.25e+1. In the year 1999, what is the difference between the Savings(current US$) of Guyana and Savings(current US$) of Saudi Arabia?
Your response must be concise. -2.55e+1. In the year 1999, what is the difference between the Savings(current US$) in Philippines and Savings(current US$) in Saudi Arabia?
Your response must be concise. -2.95e+09. In the year 2000, what is the difference between the Savings(current US$) in Guyana and Savings(current US$) in Philippines?
Ensure brevity in your answer.  -2.62e+1. In the year 2000, what is the difference between the Savings(current US$) in Guyana and Savings(current US$) in Saudi Arabia?
Provide a short and direct response. -4.06e+1. In the year 2000, what is the difference between the Savings(current US$) of Philippines and Savings(current US$) of Saudi Arabia?
Provide a succinct answer. -1.45e+1. In the year 2001, what is the difference between the Savings(current US$) in Guyana and Savings(current US$) in Philippines?
Provide a succinct answer. -2.57e+1. In the year 2001, what is the difference between the Savings(current US$) of Guyana and Savings(current US$) of Saudi Arabia?
Your response must be concise. -2.98e+1. In the year 2001, what is the difference between the Savings(current US$) of Philippines and Savings(current US$) of Saudi Arabia?
Your answer should be compact. -4.08e+09. What is the ratio of the Savings(current US$) of Argentina in 1994 to that in 1995?
Give a very brief answer. 1.1. What is the ratio of the Savings(current US$) in Guyana in 1994 to that in 1995?
Provide a short and direct response. 0.54. What is the ratio of the Savings(current US$) in Philippines in 1994 to that in 1995?
Your answer should be compact. 1.14. What is the ratio of the Savings(current US$) of Saudi Arabia in 1994 to that in 1995?
Make the answer very short. 0.51. What is the ratio of the Savings(current US$) of Argentina in 1994 to that in 1996?
Keep it short and to the point. 1.08. What is the ratio of the Savings(current US$) in Guyana in 1994 to that in 1996?
Offer a terse response. 0.47. What is the ratio of the Savings(current US$) in Philippines in 1994 to that in 1996?
Your answer should be compact. 0.91. What is the ratio of the Savings(current US$) of Saudi Arabia in 1994 to that in 1996?
Your answer should be compact. 0.32. What is the ratio of the Savings(current US$) in Argentina in 1994 to that in 1997?
Your response must be concise. 2.02. What is the ratio of the Savings(current US$) in Guyana in 1994 to that in 1997?
Provide a succinct answer. 0.64. What is the ratio of the Savings(current US$) in Philippines in 1994 to that in 1997?
Offer a very short reply. 0.79. What is the ratio of the Savings(current US$) in Saudi Arabia in 1994 to that in 1997?
Your response must be concise. 0.28. What is the ratio of the Savings(current US$) of Argentina in 1994 to that in 1998?
Your answer should be compact. 2.23. What is the ratio of the Savings(current US$) of Guyana in 1994 to that in 1998?
Offer a very short reply. 0.9. What is the ratio of the Savings(current US$) in Philippines in 1994 to that in 1998?
Your answer should be very brief. 0.57. What is the ratio of the Savings(current US$) in Saudi Arabia in 1994 to that in 1998?
Ensure brevity in your answer.  0.78. What is the ratio of the Savings(current US$) in Argentina in 1994 to that in 1999?
Make the answer very short. 20.5. What is the ratio of the Savings(current US$) of Guyana in 1994 to that in 1999?
Your response must be concise. 0.85. What is the ratio of the Savings(current US$) in Philippines in 1994 to that in 1999?
Your response must be concise. 0.37. What is the ratio of the Savings(current US$) of Saudi Arabia in 1994 to that in 1999?
Provide a succinct answer. 0.25. What is the ratio of the Savings(current US$) of Guyana in 1994 to that in 2000?
Your answer should be compact. 1.59. What is the ratio of the Savings(current US$) in Philippines in 1994 to that in 2000?
Make the answer very short. 0.32. What is the ratio of the Savings(current US$) of Saudi Arabia in 1994 to that in 2000?
Offer a terse response. 0.16. What is the ratio of the Savings(current US$) of Guyana in 1994 to that in 2001?
Give a very brief answer. 7.32. What is the ratio of the Savings(current US$) in Philippines in 1994 to that in 2001?
Your answer should be very brief. 0.33. What is the ratio of the Savings(current US$) in Saudi Arabia in 1994 to that in 2001?
Your answer should be compact. 0.22. What is the ratio of the Savings(current US$) in Argentina in 1995 to that in 1996?
Your answer should be compact. 0.98. What is the ratio of the Savings(current US$) in Guyana in 1995 to that in 1996?
Your answer should be very brief. 0.88. What is the ratio of the Savings(current US$) in Philippines in 1995 to that in 1996?
Keep it short and to the point. 0.8. What is the ratio of the Savings(current US$) in Saudi Arabia in 1995 to that in 1996?
Your response must be concise. 0.63. What is the ratio of the Savings(current US$) in Argentina in 1995 to that in 1997?
Make the answer very short. 1.83. What is the ratio of the Savings(current US$) in Guyana in 1995 to that in 1997?
Your answer should be compact. 1.18. What is the ratio of the Savings(current US$) in Philippines in 1995 to that in 1997?
Ensure brevity in your answer.  0.7. What is the ratio of the Savings(current US$) of Saudi Arabia in 1995 to that in 1997?
Make the answer very short. 0.55. What is the ratio of the Savings(current US$) of Argentina in 1995 to that in 1998?
Your answer should be very brief. 2.02. What is the ratio of the Savings(current US$) in Guyana in 1995 to that in 1998?
Keep it short and to the point. 1.67. What is the ratio of the Savings(current US$) in Philippines in 1995 to that in 1998?
Provide a short and direct response. 0.5. What is the ratio of the Savings(current US$) of Saudi Arabia in 1995 to that in 1998?
Your response must be concise. 1.52. What is the ratio of the Savings(current US$) in Argentina in 1995 to that in 1999?
Provide a succinct answer. 18.59. What is the ratio of the Savings(current US$) in Guyana in 1995 to that in 1999?
Your response must be concise. 1.57. What is the ratio of the Savings(current US$) of Philippines in 1995 to that in 1999?
Ensure brevity in your answer.  0.33. What is the ratio of the Savings(current US$) in Saudi Arabia in 1995 to that in 1999?
Provide a succinct answer. 0.5. What is the ratio of the Savings(current US$) in Guyana in 1995 to that in 2000?
Offer a very short reply. 2.95. What is the ratio of the Savings(current US$) in Philippines in 1995 to that in 2000?
Provide a succinct answer. 0.28. What is the ratio of the Savings(current US$) of Saudi Arabia in 1995 to that in 2000?
Offer a terse response. 0.31. What is the ratio of the Savings(current US$) in Guyana in 1995 to that in 2001?
Provide a succinct answer. 13.57. What is the ratio of the Savings(current US$) of Philippines in 1995 to that in 2001?
Your response must be concise. 0.29. What is the ratio of the Savings(current US$) in Saudi Arabia in 1995 to that in 2001?
Your answer should be compact. 0.43. What is the ratio of the Savings(current US$) of Argentina in 1996 to that in 1997?
Offer a terse response. 1.86. What is the ratio of the Savings(current US$) of Guyana in 1996 to that in 1997?
Offer a terse response. 1.35. What is the ratio of the Savings(current US$) in Philippines in 1996 to that in 1997?
Your answer should be very brief. 0.87. What is the ratio of the Savings(current US$) of Saudi Arabia in 1996 to that in 1997?
Offer a very short reply. 0.87. What is the ratio of the Savings(current US$) of Argentina in 1996 to that in 1998?
Provide a short and direct response. 2.06. What is the ratio of the Savings(current US$) of Guyana in 1996 to that in 1998?
Provide a succinct answer. 1.9. What is the ratio of the Savings(current US$) of Philippines in 1996 to that in 1998?
Your response must be concise. 0.63. What is the ratio of the Savings(current US$) of Saudi Arabia in 1996 to that in 1998?
Make the answer very short. 2.41. What is the ratio of the Savings(current US$) in Argentina in 1996 to that in 1999?
Provide a short and direct response. 18.91. What is the ratio of the Savings(current US$) of Guyana in 1996 to that in 1999?
Your response must be concise. 1.79. What is the ratio of the Savings(current US$) in Philippines in 1996 to that in 1999?
Your answer should be very brief. 0.41. What is the ratio of the Savings(current US$) of Saudi Arabia in 1996 to that in 1999?
Give a very brief answer. 0.79. What is the ratio of the Savings(current US$) in Guyana in 1996 to that in 2000?
Your answer should be compact. 3.35. What is the ratio of the Savings(current US$) in Philippines in 1996 to that in 2000?
Keep it short and to the point. 0.35. What is the ratio of the Savings(current US$) of Saudi Arabia in 1996 to that in 2000?
Ensure brevity in your answer.  0.5. What is the ratio of the Savings(current US$) of Guyana in 1996 to that in 2001?
Offer a very short reply. 15.43. What is the ratio of the Savings(current US$) of Philippines in 1996 to that in 2001?
Provide a short and direct response. 0.36. What is the ratio of the Savings(current US$) of Saudi Arabia in 1996 to that in 2001?
Your answer should be compact. 0.68. What is the ratio of the Savings(current US$) in Argentina in 1997 to that in 1998?
Your response must be concise. 1.11. What is the ratio of the Savings(current US$) of Guyana in 1997 to that in 1998?
Your answer should be very brief. 1.41. What is the ratio of the Savings(current US$) of Philippines in 1997 to that in 1998?
Your answer should be compact. 0.72. What is the ratio of the Savings(current US$) of Saudi Arabia in 1997 to that in 1998?
Offer a terse response. 2.78. What is the ratio of the Savings(current US$) in Argentina in 1997 to that in 1999?
Keep it short and to the point. 10.16. What is the ratio of the Savings(current US$) in Guyana in 1997 to that in 1999?
Offer a terse response. 1.33. What is the ratio of the Savings(current US$) of Philippines in 1997 to that in 1999?
Your answer should be very brief. 0.47. What is the ratio of the Savings(current US$) in Saudi Arabia in 1997 to that in 1999?
Provide a short and direct response. 0.91. What is the ratio of the Savings(current US$) of Guyana in 1997 to that in 2000?
Ensure brevity in your answer.  2.49. What is the ratio of the Savings(current US$) in Philippines in 1997 to that in 2000?
Provide a succinct answer. 0.4. What is the ratio of the Savings(current US$) of Saudi Arabia in 1997 to that in 2000?
Your answer should be very brief. 0.57. What is the ratio of the Savings(current US$) in Guyana in 1997 to that in 2001?
Your response must be concise. 11.47. What is the ratio of the Savings(current US$) in Philippines in 1997 to that in 2001?
Provide a succinct answer. 0.41. What is the ratio of the Savings(current US$) in Saudi Arabia in 1997 to that in 2001?
Make the answer very short. 0.78. What is the ratio of the Savings(current US$) in Argentina in 1998 to that in 1999?
Offer a terse response. 9.18. What is the ratio of the Savings(current US$) of Guyana in 1998 to that in 1999?
Keep it short and to the point. 0.94. What is the ratio of the Savings(current US$) of Philippines in 1998 to that in 1999?
Your answer should be compact. 0.65. What is the ratio of the Savings(current US$) in Saudi Arabia in 1998 to that in 1999?
Provide a short and direct response. 0.33. What is the ratio of the Savings(current US$) of Guyana in 1998 to that in 2000?
Provide a succinct answer. 1.76. What is the ratio of the Savings(current US$) in Philippines in 1998 to that in 2000?
Your answer should be very brief. 0.56. What is the ratio of the Savings(current US$) in Saudi Arabia in 1998 to that in 2000?
Provide a short and direct response. 0.21. What is the ratio of the Savings(current US$) in Guyana in 1998 to that in 2001?
Offer a terse response. 8.11. What is the ratio of the Savings(current US$) in Philippines in 1998 to that in 2001?
Ensure brevity in your answer.  0.57. What is the ratio of the Savings(current US$) in Saudi Arabia in 1998 to that in 2001?
Provide a short and direct response. 0.28. What is the ratio of the Savings(current US$) of Guyana in 1999 to that in 2000?
Provide a succinct answer. 1.87. What is the ratio of the Savings(current US$) in Philippines in 1999 to that in 2000?
Make the answer very short. 0.86. What is the ratio of the Savings(current US$) in Saudi Arabia in 1999 to that in 2000?
Keep it short and to the point. 0.63. What is the ratio of the Savings(current US$) in Guyana in 1999 to that in 2001?
Give a very brief answer. 8.63. What is the ratio of the Savings(current US$) in Philippines in 1999 to that in 2001?
Offer a very short reply. 0.88. What is the ratio of the Savings(current US$) of Saudi Arabia in 1999 to that in 2001?
Make the answer very short. 0.86. What is the ratio of the Savings(current US$) in Guyana in 2000 to that in 2001?
Provide a short and direct response. 4.6. What is the ratio of the Savings(current US$) in Philippines in 2000 to that in 2001?
Keep it short and to the point. 1.02. What is the ratio of the Savings(current US$) of Saudi Arabia in 2000 to that in 2001?
Offer a terse response. 1.37. What is the difference between the highest and the second highest Savings(current US$) in Argentina?
Make the answer very short. 1.45e+09. What is the difference between the highest and the second highest Savings(current US$) in Guyana?
Offer a terse response. 1.91e+07. What is the difference between the highest and the second highest Savings(current US$) in Philippines?
Ensure brevity in your answer.  4.96e+08. What is the difference between the highest and the second highest Savings(current US$) in Saudi Arabia?
Your answer should be very brief. 1.09e+1. What is the difference between the highest and the lowest Savings(current US$) of Argentina?
Offer a terse response. 1.88e+1. What is the difference between the highest and the lowest Savings(current US$) in Guyana?
Offer a terse response. 1.48e+08. What is the difference between the highest and the lowest Savings(current US$) in Philippines?
Make the answer very short. 1.88e+1. What is the difference between the highest and the lowest Savings(current US$) of Saudi Arabia?
Your answer should be very brief. 3.42e+1. 